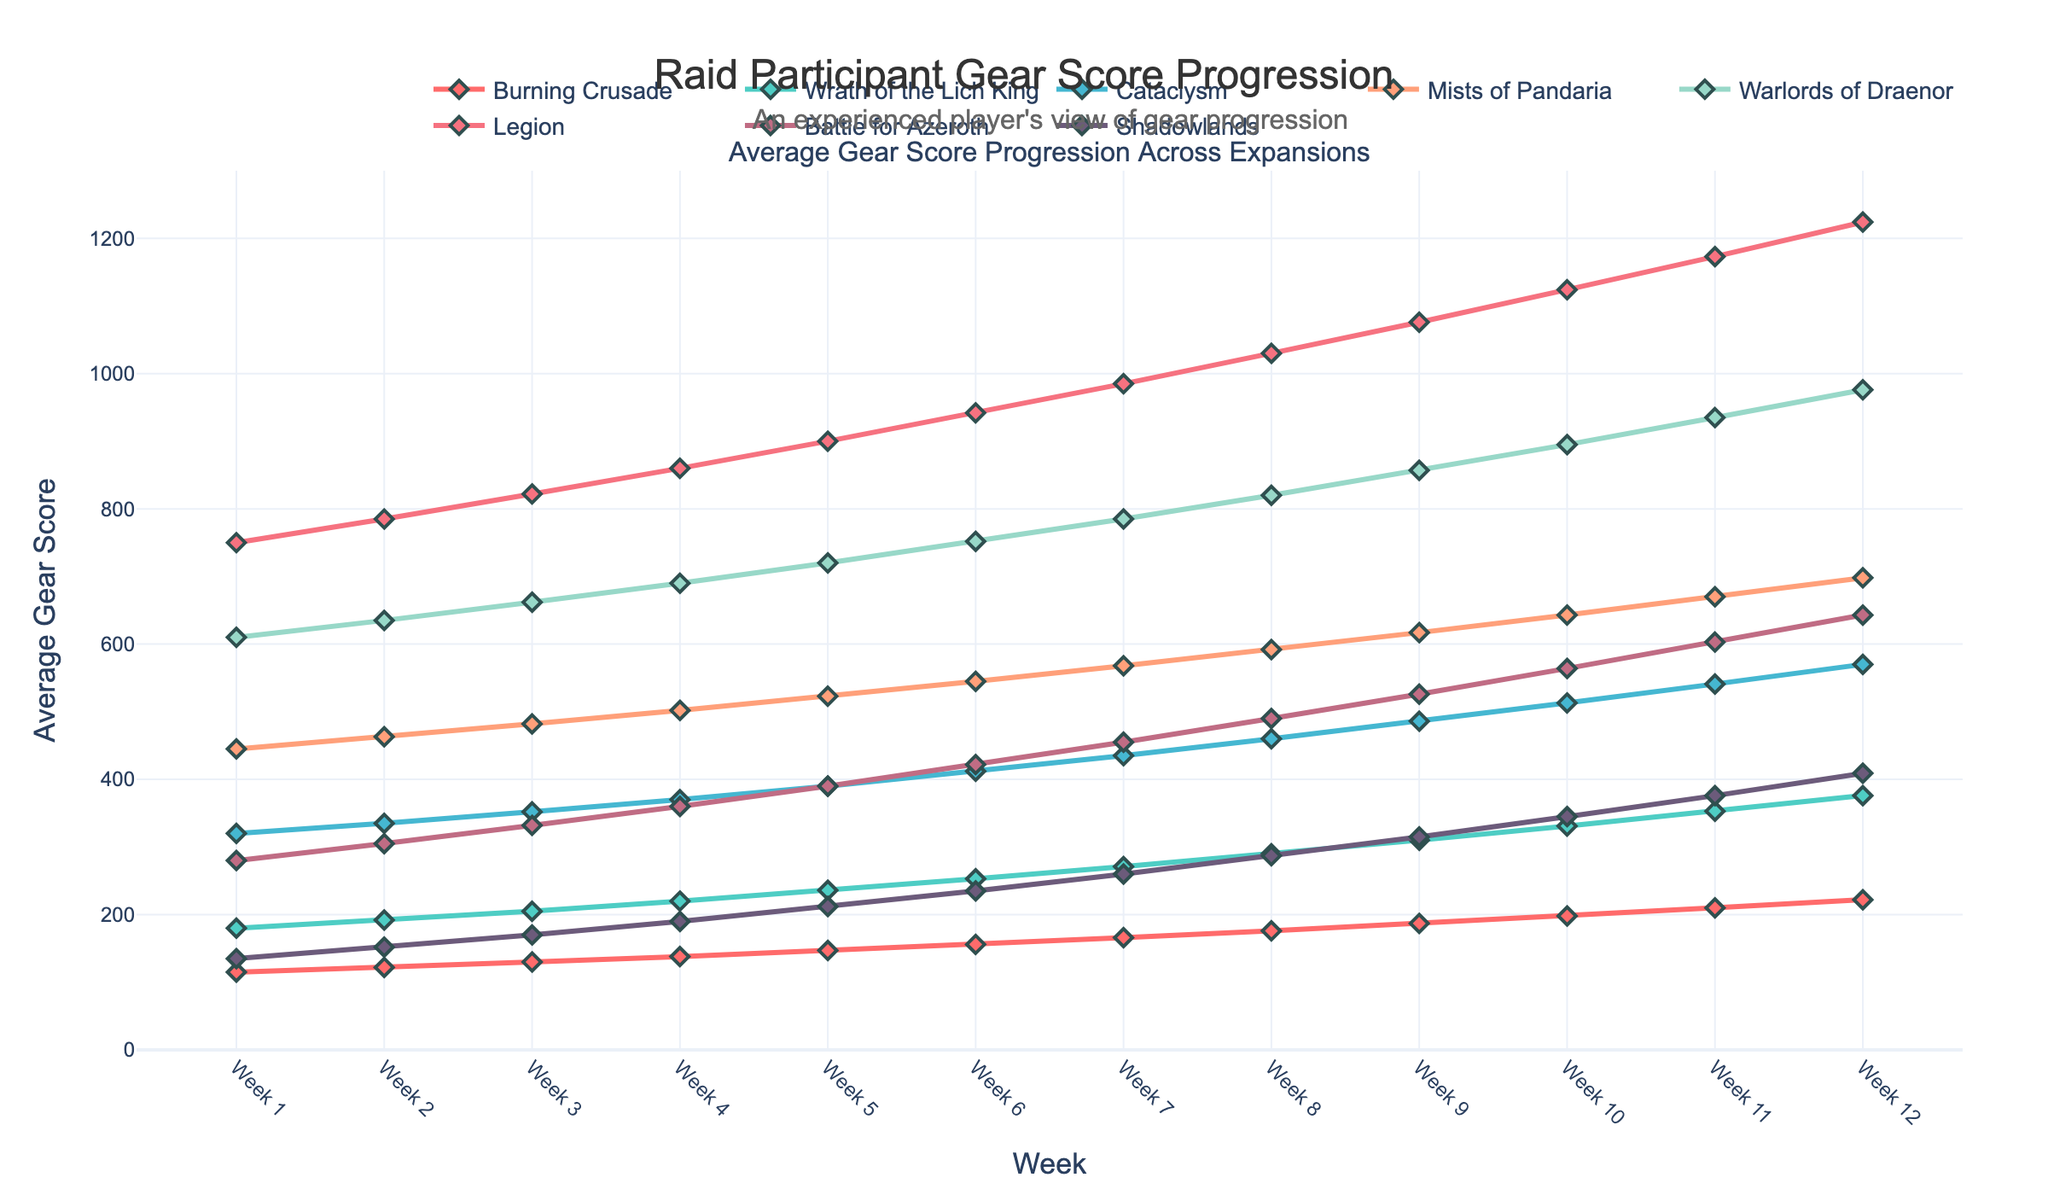What trend is observed in the gear score progression for the "Legion" expansion over the 12 weeks? The "Legion" expansion shows a consistent increasing trend in gear score progression. Starting from Week 1 at a gear score of 750, it increases almost linearly each week, reaching 1224 by Week 12. This demonstrates a regular improvement in gear score as the weeks progress.
Answer: Consistent increase Which expansion has the highest gear score at Week 6 and what is its value? At Week 6, "Legion" has the highest gear score among all expansions, with a value of 942. By visually identifying the highest marker at Week 6, we can determine that "Legion" surpasses the other expansions.
Answer: Legion, 942 Between Weeks 3 and 7, which expansions have the slowest progression in gear scores, and how can you identify them? "Battle for Azeroth" and "Shadowlands" exhibit the slowest progression between Weeks 3 and 7. By observing the slopes of the lines for these expansions, we note that their gear scores increase at a slower rate compared to other expansions within this time frame. "Battle for Azeroth" goes from 332 to 455 and "Shadowlands" from 170 to 260, which is relatively slower.
Answer: Battle for Azeroth and Shadowlands Which expansion shows the most significant gear score increase between Week 9 and Week 12? "Legion" shows the most significant gear score increase between Week 9 and Week 12. By comparing the increase for each expansion, "Legion" rises from 1076 to 1224, a difference of 148 points. This is the largest increase among all expansions in that period.
Answer: Legion What is the total gear score improvement for "Mists of Pandaria" from Week 1 to Week 12? The total gear score improvement for "Mists of Pandaria" is calculated by subtracting the Week 1 value from the Week 12 value. Starting from 445 in Week 1 and reaching 698 in Week 12, the improvement is 698 - 445 = 253.
Answer: 253 Which expansions' gear scores intersect around Week 5 and what are their values? The gear scores for "Cataclysm" and "Burning Crusade" intersect around Week 5. By visually inspecting the plot, we see that around Week 5, both expansions have gear scores ranging from 370 to 410. The gear score of "Cataclysm" slightly surpasses "Burning Crusade" after this intersection.
Answer: Cataclysm and Burning Crusade How does the visual representation of "Legion" differ from other expansions in terms of color and marker style? The "Legion" expansion is visually represented with a distinctive vivid color (not specified, but identifiable in the plot) and uses diamond-shaped markers with a prominent size and border, distinguishing it from other expansions. These visual features make the "Legion" line standout.
Answer: Vivid color, diamond-shaped markers Which expansion has the highest initial gear score and what is the value? "Legion" has the highest initial gear score at Week 1, with a value of 750. By observing the plot at the start (Week 1), the line for "Legion" is clearly at a higher gear score than any other expansion.
Answer: Legion, 750 